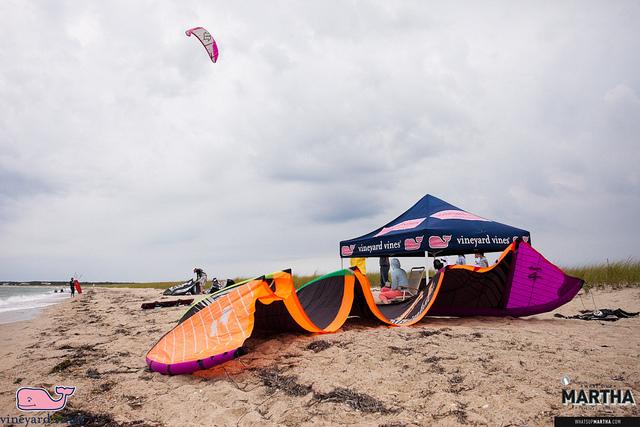What are people doing?
Give a very brief answer. Flying kites. What does it say on the tent?
Concise answer only. Vineyard vines. What is blocking the people from the sun?
Short answer required. Canopy. 